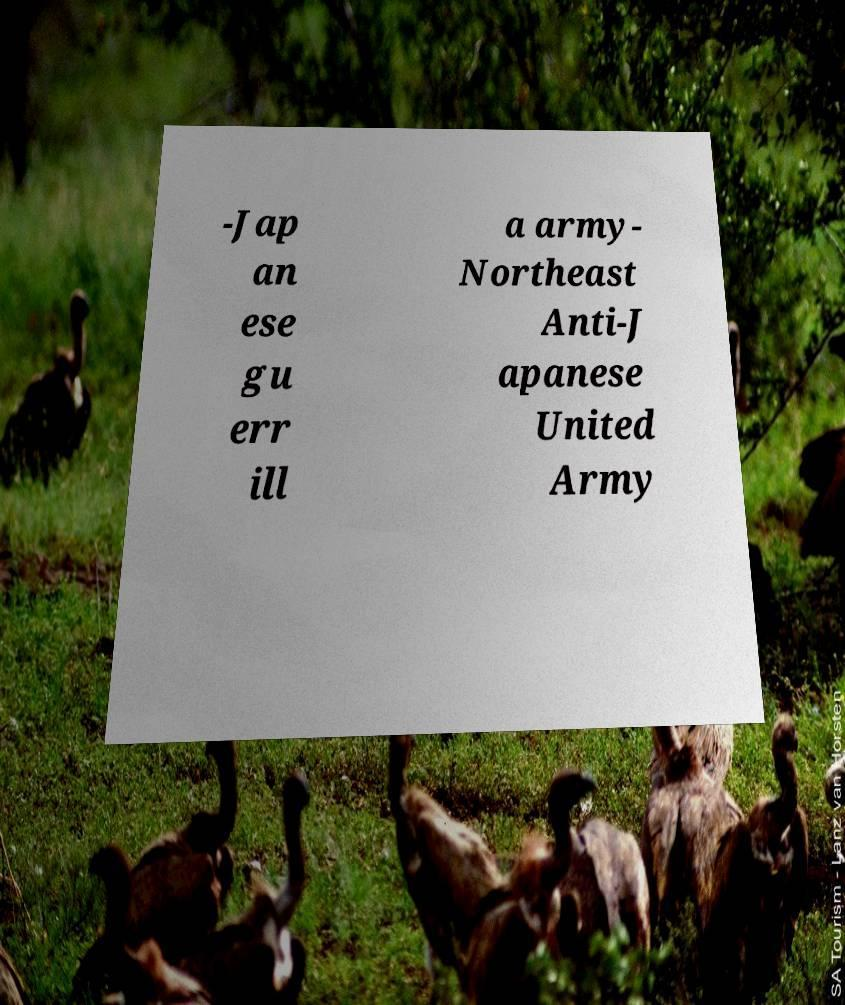Could you assist in decoding the text presented in this image and type it out clearly? -Jap an ese gu err ill a army- Northeast Anti-J apanese United Army 